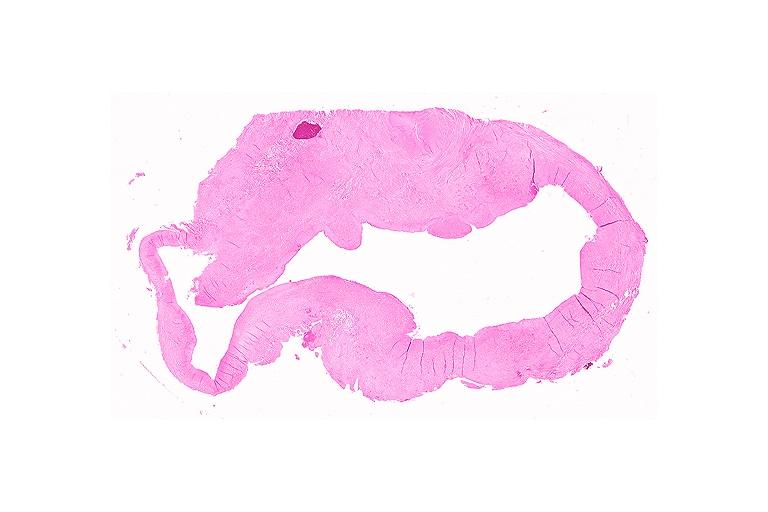what does this image show?
Answer the question using a single word or phrase. Cyst 